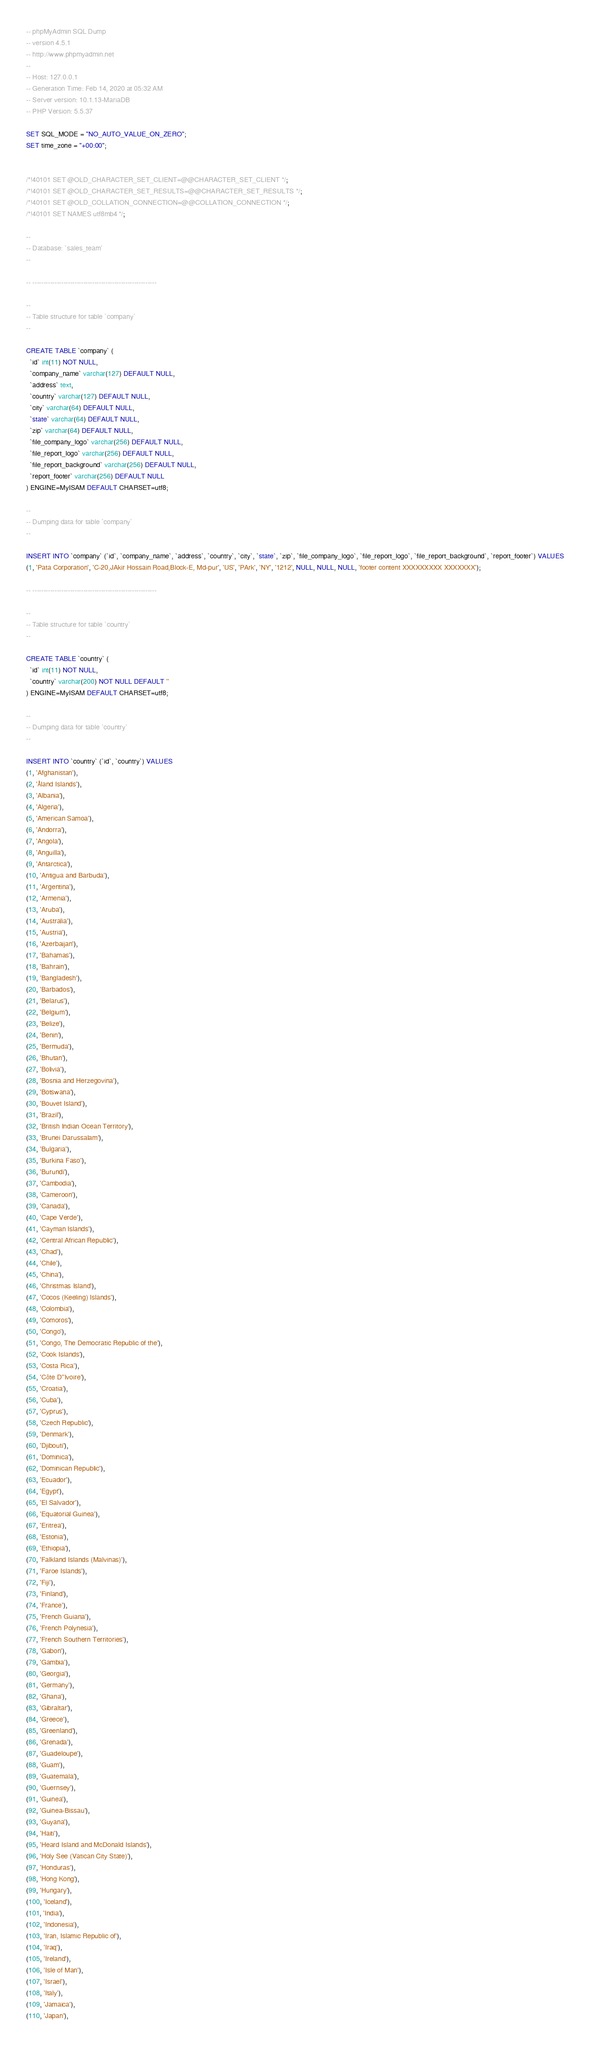Convert code to text. <code><loc_0><loc_0><loc_500><loc_500><_SQL_>-- phpMyAdmin SQL Dump
-- version 4.5.1
-- http://www.phpmyadmin.net
--
-- Host: 127.0.0.1
-- Generation Time: Feb 14, 2020 at 05:32 AM
-- Server version: 10.1.13-MariaDB
-- PHP Version: 5.5.37

SET SQL_MODE = "NO_AUTO_VALUE_ON_ZERO";
SET time_zone = "+00:00";


/*!40101 SET @OLD_CHARACTER_SET_CLIENT=@@CHARACTER_SET_CLIENT */;
/*!40101 SET @OLD_CHARACTER_SET_RESULTS=@@CHARACTER_SET_RESULTS */;
/*!40101 SET @OLD_COLLATION_CONNECTION=@@COLLATION_CONNECTION */;
/*!40101 SET NAMES utf8mb4 */;

--
-- Database: `sales_team`
--

-- --------------------------------------------------------

--
-- Table structure for table `company`
--

CREATE TABLE `company` (
  `id` int(11) NOT NULL,
  `company_name` varchar(127) DEFAULT NULL,
  `address` text,
  `country` varchar(127) DEFAULT NULL,
  `city` varchar(64) DEFAULT NULL,
  `state` varchar(64) DEFAULT NULL,
  `zip` varchar(64) DEFAULT NULL,
  `file_company_logo` varchar(256) DEFAULT NULL,
  `file_report_logo` varchar(256) DEFAULT NULL,
  `file_report_background` varchar(256) DEFAULT NULL,
  `report_footer` varchar(256) DEFAULT NULL
) ENGINE=MyISAM DEFAULT CHARSET=utf8;

--
-- Dumping data for table `company`
--

INSERT INTO `company` (`id`, `company_name`, `address`, `country`, `city`, `state`, `zip`, `file_company_logo`, `file_report_logo`, `file_report_background`, `report_footer`) VALUES
(1, 'Pata Corporation', 'C-20,JAkir Hossain Road,Block-E, Md-pur', 'US', 'PArk', 'NY', '1212', NULL, NULL, NULL, 'footer content XXXXXXXXX XXXXXXX');

-- --------------------------------------------------------

--
-- Table structure for table `country`
--

CREATE TABLE `country` (
  `id` int(11) NOT NULL,
  `country` varchar(200) NOT NULL DEFAULT ''
) ENGINE=MyISAM DEFAULT CHARSET=utf8;

--
-- Dumping data for table `country`
--

INSERT INTO `country` (`id`, `country`) VALUES
(1, 'Afghanistan'),
(2, 'Åland Islands'),
(3, 'Albania'),
(4, 'Algeria'),
(5, 'American Samoa'),
(6, 'Andorra'),
(7, 'Angola'),
(8, 'Anguilla'),
(9, 'Antarctica'),
(10, 'Antigua and Barbuda'),
(11, 'Argentina'),
(12, 'Armenia'),
(13, 'Aruba'),
(14, 'Australia'),
(15, 'Austria'),
(16, 'Azerbaijan'),
(17, 'Bahamas'),
(18, 'Bahrain'),
(19, 'Bangladesh'),
(20, 'Barbados'),
(21, 'Belarus'),
(22, 'Belgium'),
(23, 'Belize'),
(24, 'Benin'),
(25, 'Bermuda'),
(26, 'Bhutan'),
(27, 'Bolivia'),
(28, 'Bosnia and Herzegovina'),
(29, 'Botswana'),
(30, 'Bouvet Island'),
(31, 'Brazil'),
(32, 'British Indian Ocean Territory'),
(33, 'Brunei Darussalam'),
(34, 'Bulgaria'),
(35, 'Burkina Faso'),
(36, 'Burundi'),
(37, 'Cambodia'),
(38, 'Cameroon'),
(39, 'Canada'),
(40, 'Cape Verde'),
(41, 'Cayman Islands'),
(42, 'Central African Republic'),
(43, 'Chad'),
(44, 'Chile'),
(45, 'China'),
(46, 'Christmas Island'),
(47, 'Cocos (Keeling) Islands'),
(48, 'Colombia'),
(49, 'Comoros'),
(50, 'Congo'),
(51, 'Congo, The Democratic Republic of the'),
(52, 'Cook Islands'),
(53, 'Costa Rica'),
(54, 'Côte D''Ivoire'),
(55, 'Croatia'),
(56, 'Cuba'),
(57, 'Cyprus'),
(58, 'Czech Republic'),
(59, 'Denmark'),
(60, 'Djibouti'),
(61, 'Dominica'),
(62, 'Dominican Republic'),
(63, 'Ecuador'),
(64, 'Egypt'),
(65, 'El Salvador'),
(66, 'Equatorial Guinea'),
(67, 'Eritrea'),
(68, 'Estonia'),
(69, 'Ethiopia'),
(70, 'Falkland Islands (Malvinas)'),
(71, 'Faroe Islands'),
(72, 'Fiji'),
(73, 'Finland'),
(74, 'France'),
(75, 'French Guiana'),
(76, 'French Polynesia'),
(77, 'French Southern Territories'),
(78, 'Gabon'),
(79, 'Gambia'),
(80, 'Georgia'),
(81, 'Germany'),
(82, 'Ghana'),
(83, 'Gibraltar'),
(84, 'Greece'),
(85, 'Greenland'),
(86, 'Grenada'),
(87, 'Guadeloupe'),
(88, 'Guam'),
(89, 'Guatemala'),
(90, 'Guernsey'),
(91, 'Guinea'),
(92, 'Guinea-Bissau'),
(93, 'Guyana'),
(94, 'Haiti'),
(95, 'Heard Island and McDonald Islands'),
(96, 'Holy See (Vatican City State)'),
(97, 'Honduras'),
(98, 'Hong Kong'),
(99, 'Hungary'),
(100, 'Iceland'),
(101, 'India'),
(102, 'Indonesia'),
(103, 'Iran, Islamic Republic of'),
(104, 'Iraq'),
(105, 'Ireland'),
(106, 'Isle of Man'),
(107, 'Israel'),
(108, 'Italy'),
(109, 'Jamaica'),
(110, 'Japan'),</code> 